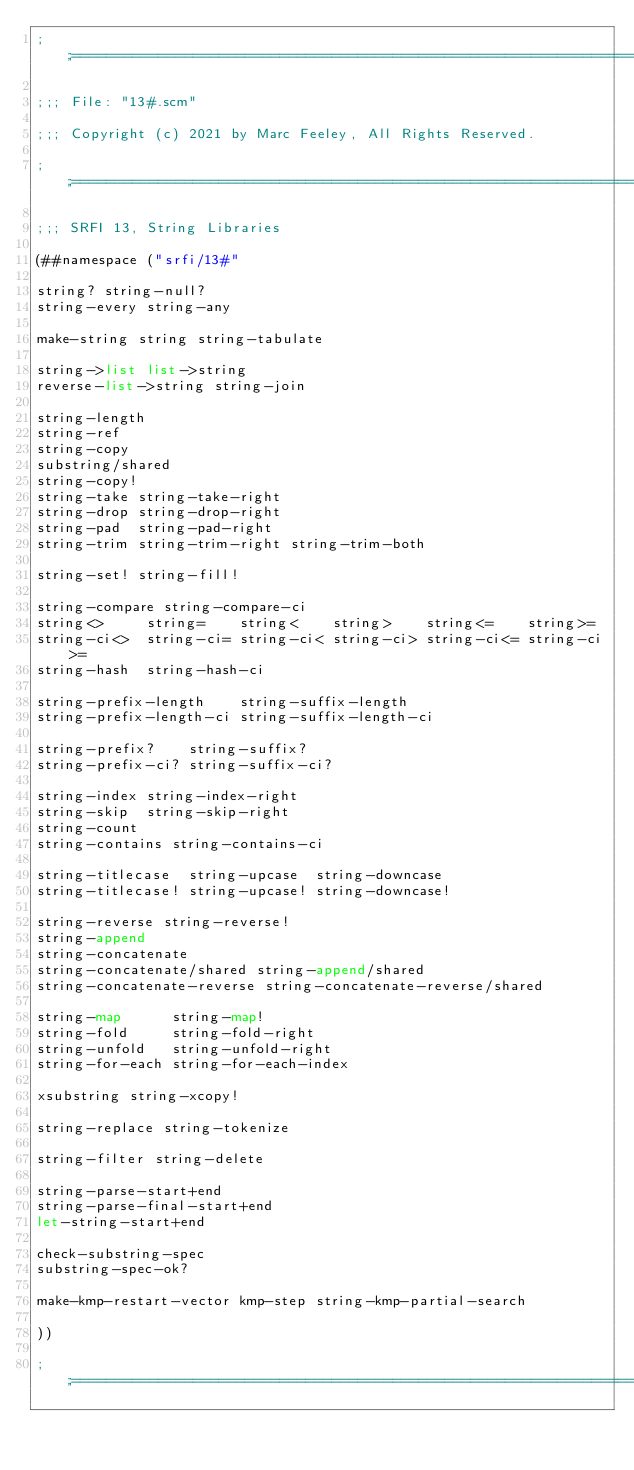Convert code to text. <code><loc_0><loc_0><loc_500><loc_500><_Scheme_>;;;============================================================================

;;; File: "13#.scm"

;;; Copyright (c) 2021 by Marc Feeley, All Rights Reserved.

;;;============================================================================

;;; SRFI 13, String Libraries

(##namespace ("srfi/13#"

string? string-null?
string-every string-any

make-string string string-tabulate

string->list list->string
reverse-list->string string-join

string-length
string-ref
string-copy
substring/shared
string-copy!
string-take string-take-right
string-drop string-drop-right
string-pad  string-pad-right
string-trim string-trim-right string-trim-both

string-set! string-fill!

string-compare string-compare-ci
string<>     string=    string<    string>    string<=    string>=
string-ci<>  string-ci= string-ci< string-ci> string-ci<= string-ci>=
string-hash  string-hash-ci

string-prefix-length    string-suffix-length
string-prefix-length-ci string-suffix-length-ci

string-prefix?    string-suffix?
string-prefix-ci? string-suffix-ci?

string-index string-index-right
string-skip  string-skip-right
string-count
string-contains string-contains-ci

string-titlecase  string-upcase  string-downcase
string-titlecase! string-upcase! string-downcase!

string-reverse string-reverse!
string-append
string-concatenate
string-concatenate/shared string-append/shared
string-concatenate-reverse string-concatenate-reverse/shared

string-map      string-map!
string-fold     string-fold-right
string-unfold   string-unfold-right
string-for-each string-for-each-index

xsubstring string-xcopy!

string-replace string-tokenize

string-filter string-delete

string-parse-start+end
string-parse-final-start+end
let-string-start+end

check-substring-spec
substring-spec-ok?

make-kmp-restart-vector kmp-step string-kmp-partial-search

))

;;;============================================================================
</code> 